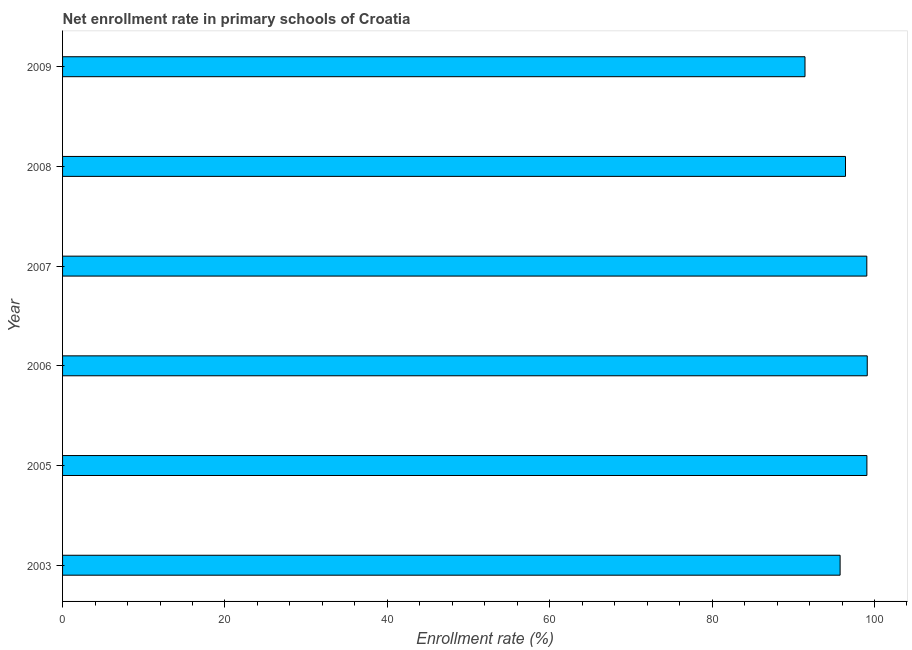Does the graph contain any zero values?
Make the answer very short. No. Does the graph contain grids?
Give a very brief answer. No. What is the title of the graph?
Ensure brevity in your answer.  Net enrollment rate in primary schools of Croatia. What is the label or title of the X-axis?
Make the answer very short. Enrollment rate (%). What is the label or title of the Y-axis?
Offer a very short reply. Year. What is the net enrollment rate in primary schools in 2008?
Ensure brevity in your answer.  96.43. Across all years, what is the maximum net enrollment rate in primary schools?
Give a very brief answer. 99.11. Across all years, what is the minimum net enrollment rate in primary schools?
Provide a succinct answer. 91.44. What is the sum of the net enrollment rate in primary schools?
Offer a very short reply. 580.86. What is the difference between the net enrollment rate in primary schools in 2008 and 2009?
Your response must be concise. 4.99. What is the average net enrollment rate in primary schools per year?
Your answer should be very brief. 96.81. What is the median net enrollment rate in primary schools?
Offer a very short reply. 97.74. In how many years, is the net enrollment rate in primary schools greater than 4 %?
Give a very brief answer. 6. Do a majority of the years between 2006 and 2005 (inclusive) have net enrollment rate in primary schools greater than 8 %?
Make the answer very short. No. Is the net enrollment rate in primary schools in 2007 less than that in 2009?
Ensure brevity in your answer.  No. What is the difference between the highest and the second highest net enrollment rate in primary schools?
Provide a succinct answer. 0.04. What is the difference between the highest and the lowest net enrollment rate in primary schools?
Keep it short and to the point. 7.67. Are all the bars in the graph horizontal?
Make the answer very short. Yes. What is the difference between two consecutive major ticks on the X-axis?
Provide a short and direct response. 20. What is the Enrollment rate (%) of 2003?
Your answer should be compact. 95.76. What is the Enrollment rate (%) in 2005?
Your answer should be very brief. 99.07. What is the Enrollment rate (%) of 2006?
Your answer should be compact. 99.11. What is the Enrollment rate (%) in 2007?
Your response must be concise. 99.05. What is the Enrollment rate (%) of 2008?
Your answer should be very brief. 96.43. What is the Enrollment rate (%) of 2009?
Provide a succinct answer. 91.44. What is the difference between the Enrollment rate (%) in 2003 and 2005?
Provide a succinct answer. -3.3. What is the difference between the Enrollment rate (%) in 2003 and 2006?
Make the answer very short. -3.34. What is the difference between the Enrollment rate (%) in 2003 and 2007?
Your answer should be very brief. -3.29. What is the difference between the Enrollment rate (%) in 2003 and 2008?
Your answer should be very brief. -0.66. What is the difference between the Enrollment rate (%) in 2003 and 2009?
Give a very brief answer. 4.33. What is the difference between the Enrollment rate (%) in 2005 and 2006?
Your response must be concise. -0.04. What is the difference between the Enrollment rate (%) in 2005 and 2007?
Make the answer very short. 0.01. What is the difference between the Enrollment rate (%) in 2005 and 2008?
Your answer should be compact. 2.64. What is the difference between the Enrollment rate (%) in 2005 and 2009?
Your answer should be compact. 7.63. What is the difference between the Enrollment rate (%) in 2006 and 2007?
Provide a succinct answer. 0.06. What is the difference between the Enrollment rate (%) in 2006 and 2008?
Offer a very short reply. 2.68. What is the difference between the Enrollment rate (%) in 2006 and 2009?
Ensure brevity in your answer.  7.67. What is the difference between the Enrollment rate (%) in 2007 and 2008?
Provide a succinct answer. 2.62. What is the difference between the Enrollment rate (%) in 2007 and 2009?
Your answer should be very brief. 7.61. What is the difference between the Enrollment rate (%) in 2008 and 2009?
Offer a very short reply. 4.99. What is the ratio of the Enrollment rate (%) in 2003 to that in 2009?
Make the answer very short. 1.05. What is the ratio of the Enrollment rate (%) in 2005 to that in 2006?
Your answer should be compact. 1. What is the ratio of the Enrollment rate (%) in 2005 to that in 2007?
Keep it short and to the point. 1. What is the ratio of the Enrollment rate (%) in 2005 to that in 2009?
Your answer should be very brief. 1.08. What is the ratio of the Enrollment rate (%) in 2006 to that in 2007?
Provide a succinct answer. 1. What is the ratio of the Enrollment rate (%) in 2006 to that in 2008?
Offer a terse response. 1.03. What is the ratio of the Enrollment rate (%) in 2006 to that in 2009?
Ensure brevity in your answer.  1.08. What is the ratio of the Enrollment rate (%) in 2007 to that in 2008?
Your answer should be compact. 1.03. What is the ratio of the Enrollment rate (%) in 2007 to that in 2009?
Your response must be concise. 1.08. What is the ratio of the Enrollment rate (%) in 2008 to that in 2009?
Offer a very short reply. 1.05. 